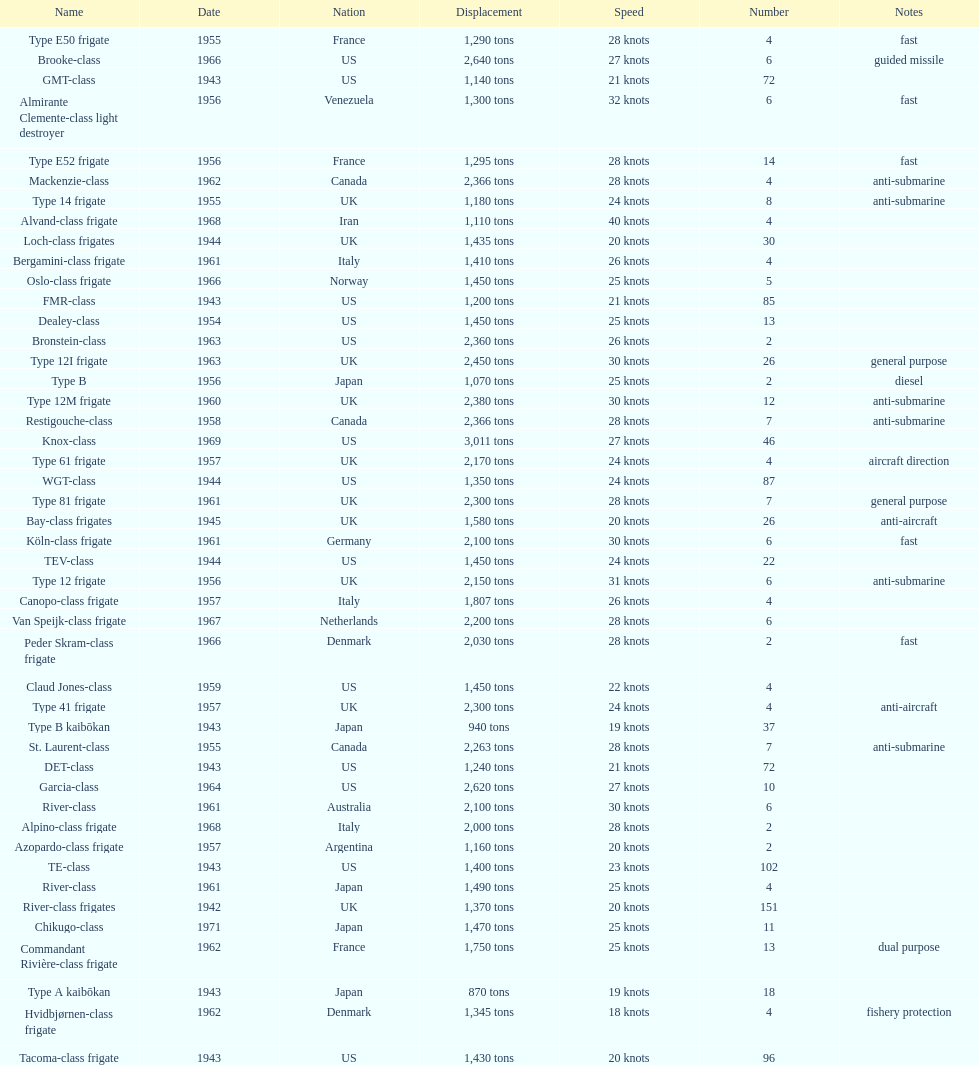I'm looking to parse the entire table for insights. Could you assist me with that? {'header': ['Name', 'Date', 'Nation', 'Displacement', 'Speed', 'Number', 'Notes'], 'rows': [['Type E50 frigate', '1955', 'France', '1,290 tons', '28 knots', '4', 'fast'], ['Brooke-class', '1966', 'US', '2,640 tons', '27 knots', '6', 'guided missile'], ['GMT-class', '1943', 'US', '1,140 tons', '21 knots', '72', ''], ['Almirante Clemente-class light destroyer', '1956', 'Venezuela', '1,300 tons', '32 knots', '6', 'fast'], ['Type E52 frigate', '1956', 'France', '1,295 tons', '28 knots', '14', 'fast'], ['Mackenzie-class', '1962', 'Canada', '2,366 tons', '28 knots', '4', 'anti-submarine'], ['Type 14 frigate', '1955', 'UK', '1,180 tons', '24 knots', '8', 'anti-submarine'], ['Alvand-class frigate', '1968', 'Iran', '1,110 tons', '40 knots', '4', ''], ['Loch-class frigates', '1944', 'UK', '1,435 tons', '20 knots', '30', ''], ['Bergamini-class frigate', '1961', 'Italy', '1,410 tons', '26 knots', '4', ''], ['Oslo-class frigate', '1966', 'Norway', '1,450 tons', '25 knots', '5', ''], ['FMR-class', '1943', 'US', '1,200 tons', '21 knots', '85', ''], ['Dealey-class', '1954', 'US', '1,450 tons', '25 knots', '13', ''], ['Bronstein-class', '1963', 'US', '2,360 tons', '26 knots', '2', ''], ['Type 12I frigate', '1963', 'UK', '2,450 tons', '30 knots', '26', 'general purpose'], ['Type B', '1956', 'Japan', '1,070 tons', '25 knots', '2', 'diesel'], ['Type 12M frigate', '1960', 'UK', '2,380 tons', '30 knots', '12', 'anti-submarine'], ['Restigouche-class', '1958', 'Canada', '2,366 tons', '28 knots', '7', 'anti-submarine'], ['Knox-class', '1969', 'US', '3,011 tons', '27 knots', '46', ''], ['Type 61 frigate', '1957', 'UK', '2,170 tons', '24 knots', '4', 'aircraft direction'], ['WGT-class', '1944', 'US', '1,350 tons', '24 knots', '87', ''], ['Type 81 frigate', '1961', 'UK', '2,300 tons', '28 knots', '7', 'general purpose'], ['Bay-class frigates', '1945', 'UK', '1,580 tons', '20 knots', '26', 'anti-aircraft'], ['Köln-class frigate', '1961', 'Germany', '2,100 tons', '30 knots', '6', 'fast'], ['TEV-class', '1944', 'US', '1,450 tons', '24 knots', '22', ''], ['Type 12 frigate', '1956', 'UK', '2,150 tons', '31 knots', '6', 'anti-submarine'], ['Canopo-class frigate', '1957', 'Italy', '1,807 tons', '26 knots', '4', ''], ['Van Speijk-class frigate', '1967', 'Netherlands', '2,200 tons', '28 knots', '6', ''], ['Peder Skram-class frigate', '1966', 'Denmark', '2,030 tons', '28 knots', '2', 'fast'], ['Claud Jones-class', '1959', 'US', '1,450 tons', '22 knots', '4', ''], ['Type 41 frigate', '1957', 'UK', '2,300 tons', '24 knots', '4', 'anti-aircraft'], ['Type B kaibōkan', '1943', 'Japan', '940 tons', '19 knots', '37', ''], ['St. Laurent-class', '1955', 'Canada', '2,263 tons', '28 knots', '7', 'anti-submarine'], ['DET-class', '1943', 'US', '1,240 tons', '21 knots', '72', ''], ['Garcia-class', '1964', 'US', '2,620 tons', '27 knots', '10', ''], ['River-class', '1961', 'Australia', '2,100 tons', '30 knots', '6', ''], ['Alpino-class frigate', '1968', 'Italy', '2,000 tons', '28 knots', '2', ''], ['Azopardo-class frigate', '1957', 'Argentina', '1,160 tons', '20 knots', '2', ''], ['TE-class', '1943', 'US', '1,400 tons', '23 knots', '102', ''], ['River-class', '1961', 'Japan', '1,490 tons', '25 knots', '4', ''], ['River-class frigates', '1942', 'UK', '1,370 tons', '20 knots', '151', ''], ['Chikugo-class', '1971', 'Japan', '1,470 tons', '25 knots', '11', ''], ['Commandant Rivière-class frigate', '1962', 'France', '1,750 tons', '25 knots', '13', 'dual purpose'], ['Type A kaibōkan', '1943', 'Japan', '870 tons', '19 knots', '18', ''], ['Hvidbjørnen-class frigate', '1962', 'Denmark', '1,345 tons', '18 knots', '4', 'fishery protection'], ['Tacoma-class frigate', '1943', 'US', '1,430 tons', '20 knots', '96', '']]} What is the difference in speed for the gmt-class and the te-class? 2 knots. 